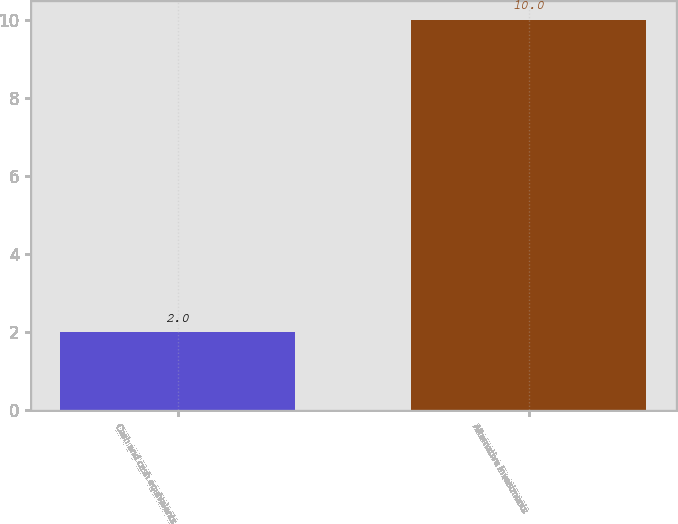Convert chart. <chart><loc_0><loc_0><loc_500><loc_500><bar_chart><fcel>Cash and cash equivalents<fcel>Alternative investments<nl><fcel>2<fcel>10<nl></chart> 